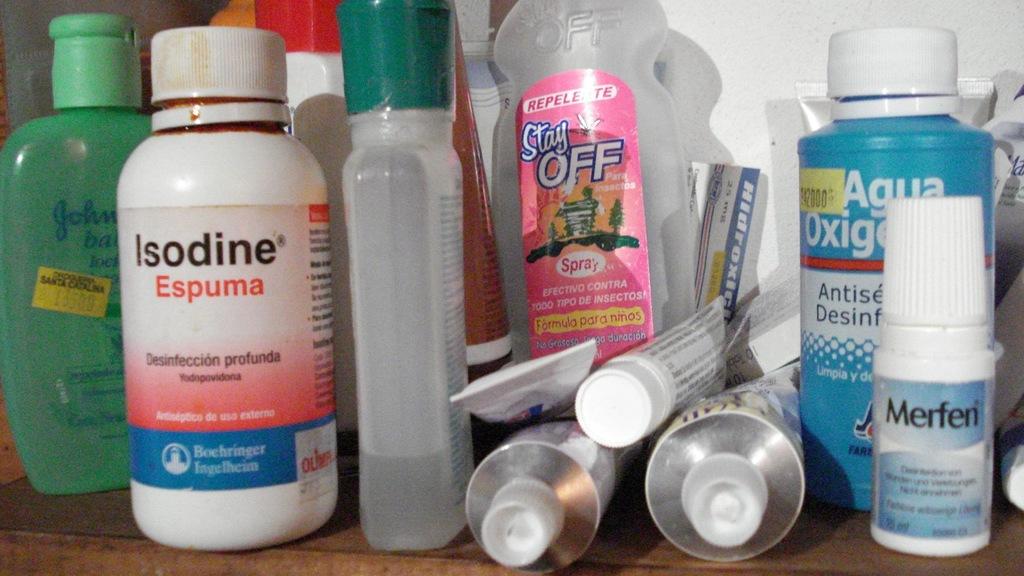What us in the small bottle on the right?
Provide a succinct answer. Merfen. 